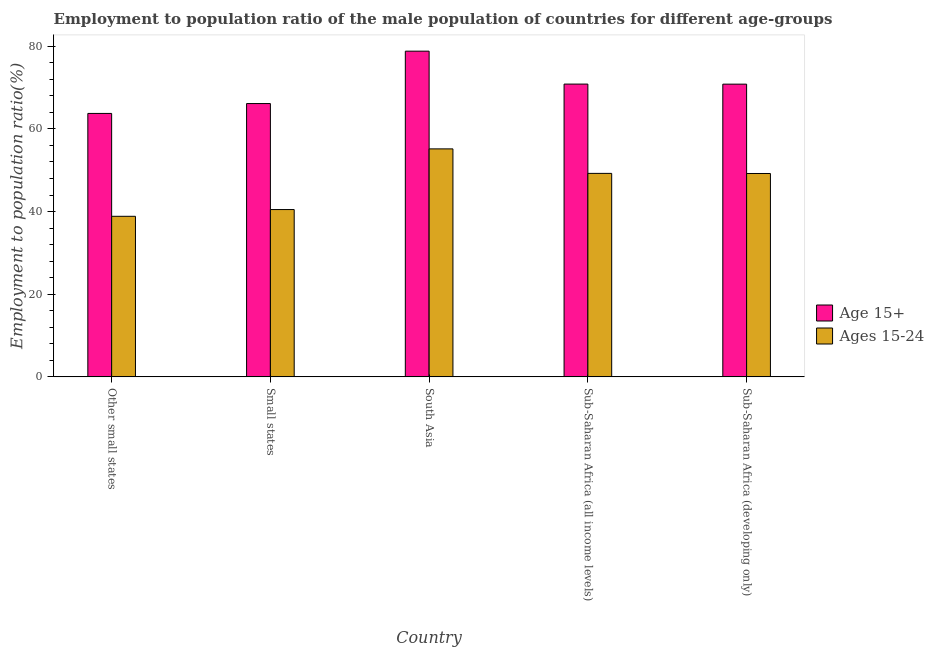How many different coloured bars are there?
Make the answer very short. 2. How many groups of bars are there?
Keep it short and to the point. 5. Are the number of bars per tick equal to the number of legend labels?
Your answer should be very brief. Yes. Are the number of bars on each tick of the X-axis equal?
Keep it short and to the point. Yes. How many bars are there on the 5th tick from the left?
Provide a short and direct response. 2. How many bars are there on the 1st tick from the right?
Offer a very short reply. 2. What is the label of the 2nd group of bars from the left?
Offer a terse response. Small states. In how many cases, is the number of bars for a given country not equal to the number of legend labels?
Offer a terse response. 0. What is the employment to population ratio(age 15+) in Small states?
Ensure brevity in your answer.  66.13. Across all countries, what is the maximum employment to population ratio(age 15-24)?
Your response must be concise. 55.16. Across all countries, what is the minimum employment to population ratio(age 15+)?
Offer a very short reply. 63.74. In which country was the employment to population ratio(age 15+) maximum?
Provide a succinct answer. South Asia. In which country was the employment to population ratio(age 15-24) minimum?
Make the answer very short. Other small states. What is the total employment to population ratio(age 15-24) in the graph?
Your answer should be very brief. 232.93. What is the difference between the employment to population ratio(age 15-24) in South Asia and that in Sub-Saharan Africa (all income levels)?
Your answer should be compact. 5.93. What is the difference between the employment to population ratio(age 15-24) in Sub-Saharan Africa (developing only) and the employment to population ratio(age 15+) in Other small states?
Keep it short and to the point. -14.53. What is the average employment to population ratio(age 15+) per country?
Your answer should be very brief. 70.07. What is the difference between the employment to population ratio(age 15+) and employment to population ratio(age 15-24) in Small states?
Your response must be concise. 25.64. What is the ratio of the employment to population ratio(age 15+) in South Asia to that in Sub-Saharan Africa (developing only)?
Your answer should be compact. 1.11. What is the difference between the highest and the second highest employment to population ratio(age 15-24)?
Make the answer very short. 5.93. What is the difference between the highest and the lowest employment to population ratio(age 15-24)?
Offer a very short reply. 16.31. In how many countries, is the employment to population ratio(age 15-24) greater than the average employment to population ratio(age 15-24) taken over all countries?
Offer a very short reply. 3. What does the 2nd bar from the left in Sub-Saharan Africa (developing only) represents?
Offer a terse response. Ages 15-24. What does the 2nd bar from the right in South Asia represents?
Ensure brevity in your answer.  Age 15+. How many bars are there?
Make the answer very short. 10. Are all the bars in the graph horizontal?
Provide a short and direct response. No. Are the values on the major ticks of Y-axis written in scientific E-notation?
Give a very brief answer. No. Does the graph contain any zero values?
Your response must be concise. No. Does the graph contain grids?
Ensure brevity in your answer.  No. Where does the legend appear in the graph?
Keep it short and to the point. Center right. How many legend labels are there?
Give a very brief answer. 2. What is the title of the graph?
Your answer should be compact. Employment to population ratio of the male population of countries for different age-groups. What is the label or title of the X-axis?
Your response must be concise. Country. What is the Employment to population ratio(%) in Age 15+ in Other small states?
Keep it short and to the point. 63.74. What is the Employment to population ratio(%) of Ages 15-24 in Other small states?
Your answer should be very brief. 38.85. What is the Employment to population ratio(%) in Age 15+ in Small states?
Offer a very short reply. 66.13. What is the Employment to population ratio(%) in Ages 15-24 in Small states?
Your answer should be compact. 40.48. What is the Employment to population ratio(%) in Age 15+ in South Asia?
Provide a succinct answer. 78.8. What is the Employment to population ratio(%) in Ages 15-24 in South Asia?
Make the answer very short. 55.16. What is the Employment to population ratio(%) of Age 15+ in Sub-Saharan Africa (all income levels)?
Offer a very short reply. 70.84. What is the Employment to population ratio(%) of Ages 15-24 in Sub-Saharan Africa (all income levels)?
Make the answer very short. 49.23. What is the Employment to population ratio(%) in Age 15+ in Sub-Saharan Africa (developing only)?
Your response must be concise. 70.82. What is the Employment to population ratio(%) of Ages 15-24 in Sub-Saharan Africa (developing only)?
Make the answer very short. 49.21. Across all countries, what is the maximum Employment to population ratio(%) of Age 15+?
Provide a short and direct response. 78.8. Across all countries, what is the maximum Employment to population ratio(%) in Ages 15-24?
Give a very brief answer. 55.16. Across all countries, what is the minimum Employment to population ratio(%) of Age 15+?
Your response must be concise. 63.74. Across all countries, what is the minimum Employment to population ratio(%) of Ages 15-24?
Give a very brief answer. 38.85. What is the total Employment to population ratio(%) in Age 15+ in the graph?
Give a very brief answer. 350.33. What is the total Employment to population ratio(%) of Ages 15-24 in the graph?
Ensure brevity in your answer.  232.93. What is the difference between the Employment to population ratio(%) in Age 15+ in Other small states and that in Small states?
Provide a succinct answer. -2.39. What is the difference between the Employment to population ratio(%) of Ages 15-24 in Other small states and that in Small states?
Ensure brevity in your answer.  -1.64. What is the difference between the Employment to population ratio(%) of Age 15+ in Other small states and that in South Asia?
Provide a succinct answer. -15.07. What is the difference between the Employment to population ratio(%) in Ages 15-24 in Other small states and that in South Asia?
Keep it short and to the point. -16.31. What is the difference between the Employment to population ratio(%) of Age 15+ in Other small states and that in Sub-Saharan Africa (all income levels)?
Offer a terse response. -7.1. What is the difference between the Employment to population ratio(%) in Ages 15-24 in Other small states and that in Sub-Saharan Africa (all income levels)?
Ensure brevity in your answer.  -10.39. What is the difference between the Employment to population ratio(%) in Age 15+ in Other small states and that in Sub-Saharan Africa (developing only)?
Provide a succinct answer. -7.09. What is the difference between the Employment to population ratio(%) in Ages 15-24 in Other small states and that in Sub-Saharan Africa (developing only)?
Keep it short and to the point. -10.36. What is the difference between the Employment to population ratio(%) of Age 15+ in Small states and that in South Asia?
Ensure brevity in your answer.  -12.68. What is the difference between the Employment to population ratio(%) of Ages 15-24 in Small states and that in South Asia?
Offer a very short reply. -14.68. What is the difference between the Employment to population ratio(%) of Age 15+ in Small states and that in Sub-Saharan Africa (all income levels)?
Provide a succinct answer. -4.71. What is the difference between the Employment to population ratio(%) of Ages 15-24 in Small states and that in Sub-Saharan Africa (all income levels)?
Your answer should be compact. -8.75. What is the difference between the Employment to population ratio(%) of Age 15+ in Small states and that in Sub-Saharan Africa (developing only)?
Give a very brief answer. -4.7. What is the difference between the Employment to population ratio(%) of Ages 15-24 in Small states and that in Sub-Saharan Africa (developing only)?
Provide a succinct answer. -8.73. What is the difference between the Employment to population ratio(%) of Age 15+ in South Asia and that in Sub-Saharan Africa (all income levels)?
Offer a very short reply. 7.97. What is the difference between the Employment to population ratio(%) in Ages 15-24 in South Asia and that in Sub-Saharan Africa (all income levels)?
Keep it short and to the point. 5.93. What is the difference between the Employment to population ratio(%) of Age 15+ in South Asia and that in Sub-Saharan Africa (developing only)?
Keep it short and to the point. 7.98. What is the difference between the Employment to population ratio(%) of Ages 15-24 in South Asia and that in Sub-Saharan Africa (developing only)?
Provide a succinct answer. 5.95. What is the difference between the Employment to population ratio(%) in Age 15+ in Sub-Saharan Africa (all income levels) and that in Sub-Saharan Africa (developing only)?
Make the answer very short. 0.01. What is the difference between the Employment to population ratio(%) in Ages 15-24 in Sub-Saharan Africa (all income levels) and that in Sub-Saharan Africa (developing only)?
Your answer should be compact. 0.02. What is the difference between the Employment to population ratio(%) in Age 15+ in Other small states and the Employment to population ratio(%) in Ages 15-24 in Small states?
Offer a very short reply. 23.25. What is the difference between the Employment to population ratio(%) of Age 15+ in Other small states and the Employment to population ratio(%) of Ages 15-24 in South Asia?
Provide a short and direct response. 8.58. What is the difference between the Employment to population ratio(%) of Age 15+ in Other small states and the Employment to population ratio(%) of Ages 15-24 in Sub-Saharan Africa (all income levels)?
Your answer should be very brief. 14.5. What is the difference between the Employment to population ratio(%) in Age 15+ in Other small states and the Employment to population ratio(%) in Ages 15-24 in Sub-Saharan Africa (developing only)?
Your answer should be very brief. 14.53. What is the difference between the Employment to population ratio(%) of Age 15+ in Small states and the Employment to population ratio(%) of Ages 15-24 in South Asia?
Provide a short and direct response. 10.97. What is the difference between the Employment to population ratio(%) in Age 15+ in Small states and the Employment to population ratio(%) in Ages 15-24 in Sub-Saharan Africa (all income levels)?
Provide a succinct answer. 16.89. What is the difference between the Employment to population ratio(%) of Age 15+ in Small states and the Employment to population ratio(%) of Ages 15-24 in Sub-Saharan Africa (developing only)?
Offer a terse response. 16.92. What is the difference between the Employment to population ratio(%) of Age 15+ in South Asia and the Employment to population ratio(%) of Ages 15-24 in Sub-Saharan Africa (all income levels)?
Ensure brevity in your answer.  29.57. What is the difference between the Employment to population ratio(%) in Age 15+ in South Asia and the Employment to population ratio(%) in Ages 15-24 in Sub-Saharan Africa (developing only)?
Offer a very short reply. 29.6. What is the difference between the Employment to population ratio(%) of Age 15+ in Sub-Saharan Africa (all income levels) and the Employment to population ratio(%) of Ages 15-24 in Sub-Saharan Africa (developing only)?
Offer a terse response. 21.63. What is the average Employment to population ratio(%) of Age 15+ per country?
Keep it short and to the point. 70.07. What is the average Employment to population ratio(%) in Ages 15-24 per country?
Provide a succinct answer. 46.59. What is the difference between the Employment to population ratio(%) in Age 15+ and Employment to population ratio(%) in Ages 15-24 in Other small states?
Your answer should be compact. 24.89. What is the difference between the Employment to population ratio(%) of Age 15+ and Employment to population ratio(%) of Ages 15-24 in Small states?
Your response must be concise. 25.64. What is the difference between the Employment to population ratio(%) of Age 15+ and Employment to population ratio(%) of Ages 15-24 in South Asia?
Offer a very short reply. 23.64. What is the difference between the Employment to population ratio(%) of Age 15+ and Employment to population ratio(%) of Ages 15-24 in Sub-Saharan Africa (all income levels)?
Your answer should be compact. 21.61. What is the difference between the Employment to population ratio(%) in Age 15+ and Employment to population ratio(%) in Ages 15-24 in Sub-Saharan Africa (developing only)?
Offer a terse response. 21.62. What is the ratio of the Employment to population ratio(%) in Age 15+ in Other small states to that in Small states?
Keep it short and to the point. 0.96. What is the ratio of the Employment to population ratio(%) in Ages 15-24 in Other small states to that in Small states?
Offer a terse response. 0.96. What is the ratio of the Employment to population ratio(%) of Age 15+ in Other small states to that in South Asia?
Give a very brief answer. 0.81. What is the ratio of the Employment to population ratio(%) in Ages 15-24 in Other small states to that in South Asia?
Your answer should be compact. 0.7. What is the ratio of the Employment to population ratio(%) in Age 15+ in Other small states to that in Sub-Saharan Africa (all income levels)?
Your answer should be compact. 0.9. What is the ratio of the Employment to population ratio(%) of Ages 15-24 in Other small states to that in Sub-Saharan Africa (all income levels)?
Keep it short and to the point. 0.79. What is the ratio of the Employment to population ratio(%) in Age 15+ in Other small states to that in Sub-Saharan Africa (developing only)?
Make the answer very short. 0.9. What is the ratio of the Employment to population ratio(%) in Ages 15-24 in Other small states to that in Sub-Saharan Africa (developing only)?
Ensure brevity in your answer.  0.79. What is the ratio of the Employment to population ratio(%) in Age 15+ in Small states to that in South Asia?
Give a very brief answer. 0.84. What is the ratio of the Employment to population ratio(%) of Ages 15-24 in Small states to that in South Asia?
Offer a very short reply. 0.73. What is the ratio of the Employment to population ratio(%) of Age 15+ in Small states to that in Sub-Saharan Africa (all income levels)?
Your answer should be compact. 0.93. What is the ratio of the Employment to population ratio(%) in Ages 15-24 in Small states to that in Sub-Saharan Africa (all income levels)?
Give a very brief answer. 0.82. What is the ratio of the Employment to population ratio(%) of Age 15+ in Small states to that in Sub-Saharan Africa (developing only)?
Provide a succinct answer. 0.93. What is the ratio of the Employment to population ratio(%) in Ages 15-24 in Small states to that in Sub-Saharan Africa (developing only)?
Your answer should be very brief. 0.82. What is the ratio of the Employment to population ratio(%) of Age 15+ in South Asia to that in Sub-Saharan Africa (all income levels)?
Make the answer very short. 1.11. What is the ratio of the Employment to population ratio(%) in Ages 15-24 in South Asia to that in Sub-Saharan Africa (all income levels)?
Give a very brief answer. 1.12. What is the ratio of the Employment to population ratio(%) in Age 15+ in South Asia to that in Sub-Saharan Africa (developing only)?
Ensure brevity in your answer.  1.11. What is the ratio of the Employment to population ratio(%) in Ages 15-24 in South Asia to that in Sub-Saharan Africa (developing only)?
Offer a very short reply. 1.12. What is the ratio of the Employment to population ratio(%) of Age 15+ in Sub-Saharan Africa (all income levels) to that in Sub-Saharan Africa (developing only)?
Your answer should be very brief. 1. What is the difference between the highest and the second highest Employment to population ratio(%) of Age 15+?
Offer a very short reply. 7.97. What is the difference between the highest and the second highest Employment to population ratio(%) in Ages 15-24?
Offer a terse response. 5.93. What is the difference between the highest and the lowest Employment to population ratio(%) of Age 15+?
Offer a very short reply. 15.07. What is the difference between the highest and the lowest Employment to population ratio(%) of Ages 15-24?
Provide a succinct answer. 16.31. 